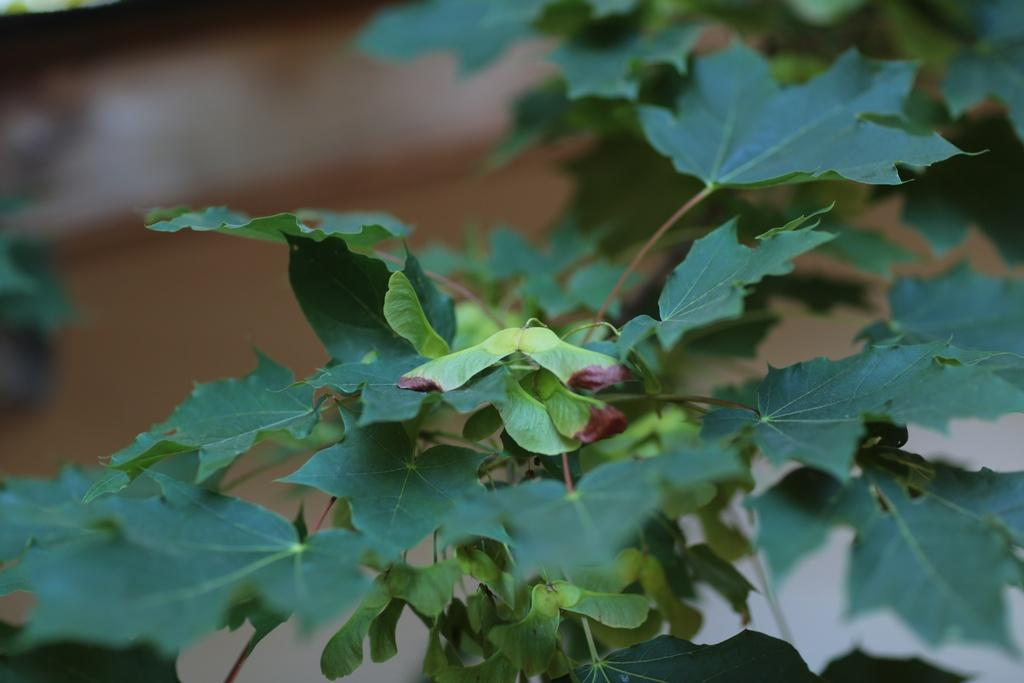What type of living organism can be seen in the image? There is a plant in the image. What part of the plant is visible in the image? Leaves are visible in the image. What is the surface beneath the plant in the image? There is ground visible in the image. What type of loaf is being baked in the image? There is no loaf or baking activity present in the image; it features a plant with leaves on the ground. 